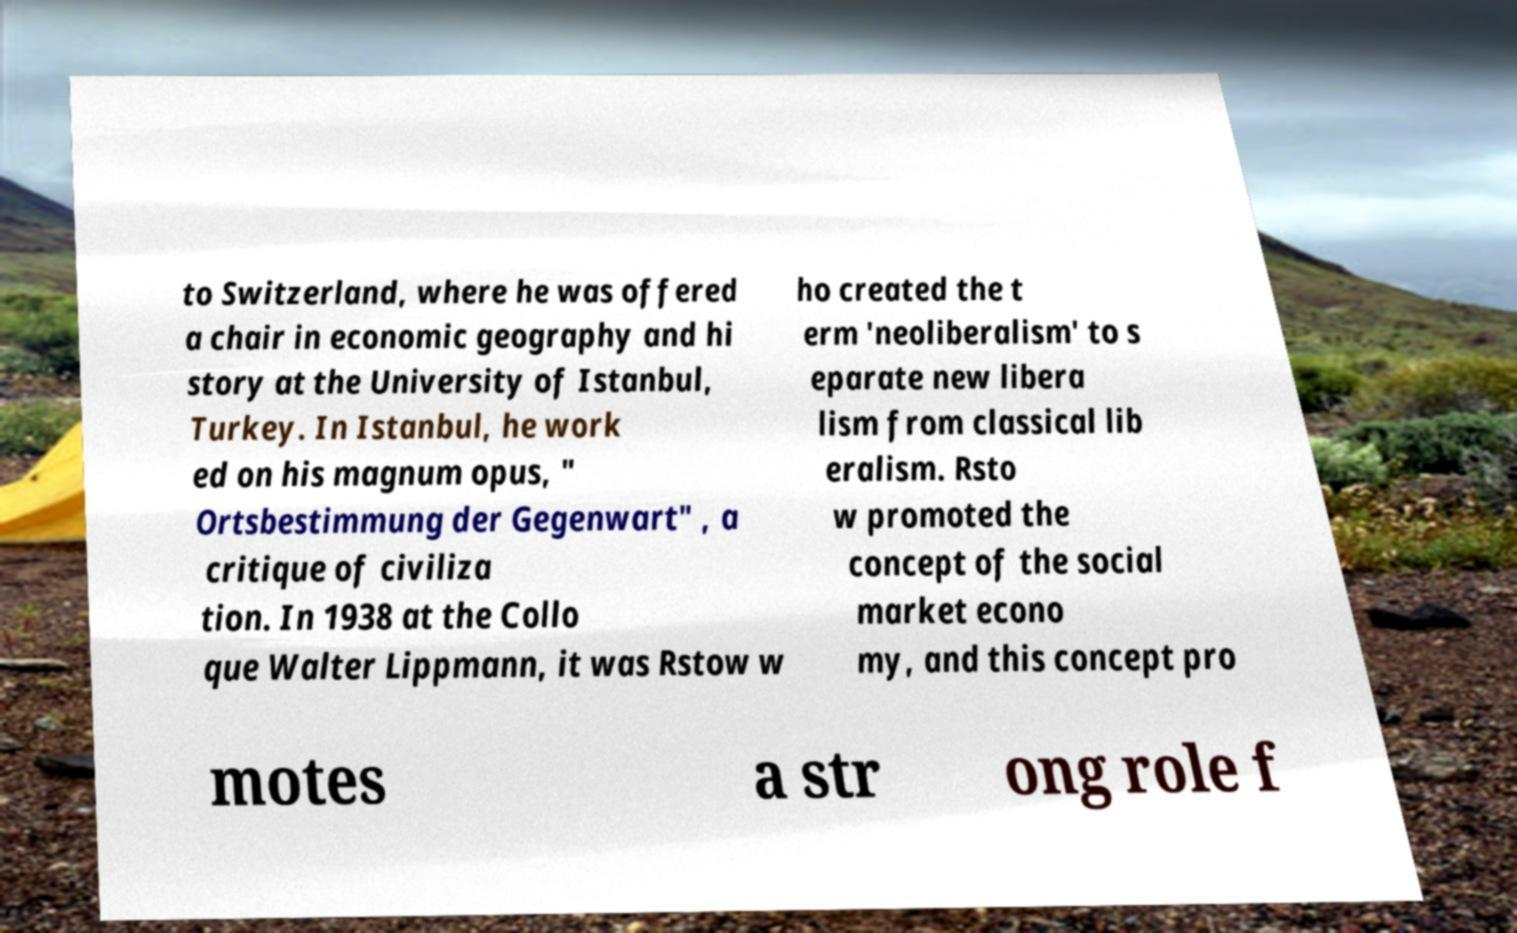Can you accurately transcribe the text from the provided image for me? to Switzerland, where he was offered a chair in economic geography and hi story at the University of Istanbul, Turkey. In Istanbul, he work ed on his magnum opus, " Ortsbestimmung der Gegenwart" , a critique of civiliza tion. In 1938 at the Collo que Walter Lippmann, it was Rstow w ho created the t erm 'neoliberalism' to s eparate new libera lism from classical lib eralism. Rsto w promoted the concept of the social market econo my, and this concept pro motes a str ong role f 